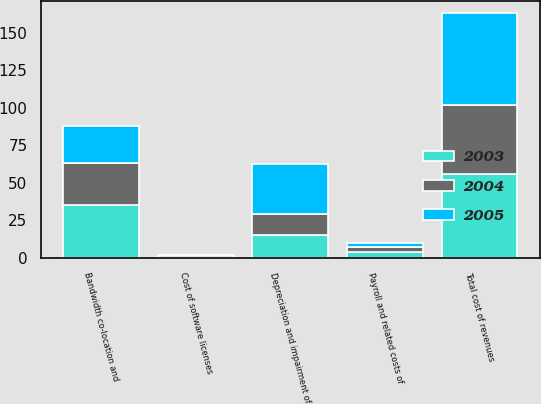<chart> <loc_0><loc_0><loc_500><loc_500><stacked_bar_chart><ecel><fcel>Bandwidth co-location and<fcel>Payroll and related costs of<fcel>Cost of software licenses<fcel>Depreciation and impairment of<fcel>Total cost of revenues<nl><fcel>2003<fcel>35.6<fcel>3.8<fcel>0.7<fcel>15.6<fcel>55.7<nl><fcel>2004<fcel>27.7<fcel>3.5<fcel>1<fcel>14<fcel>46.2<nl><fcel>2005<fcel>24.5<fcel>2.9<fcel>0.4<fcel>33<fcel>60.8<nl></chart> 